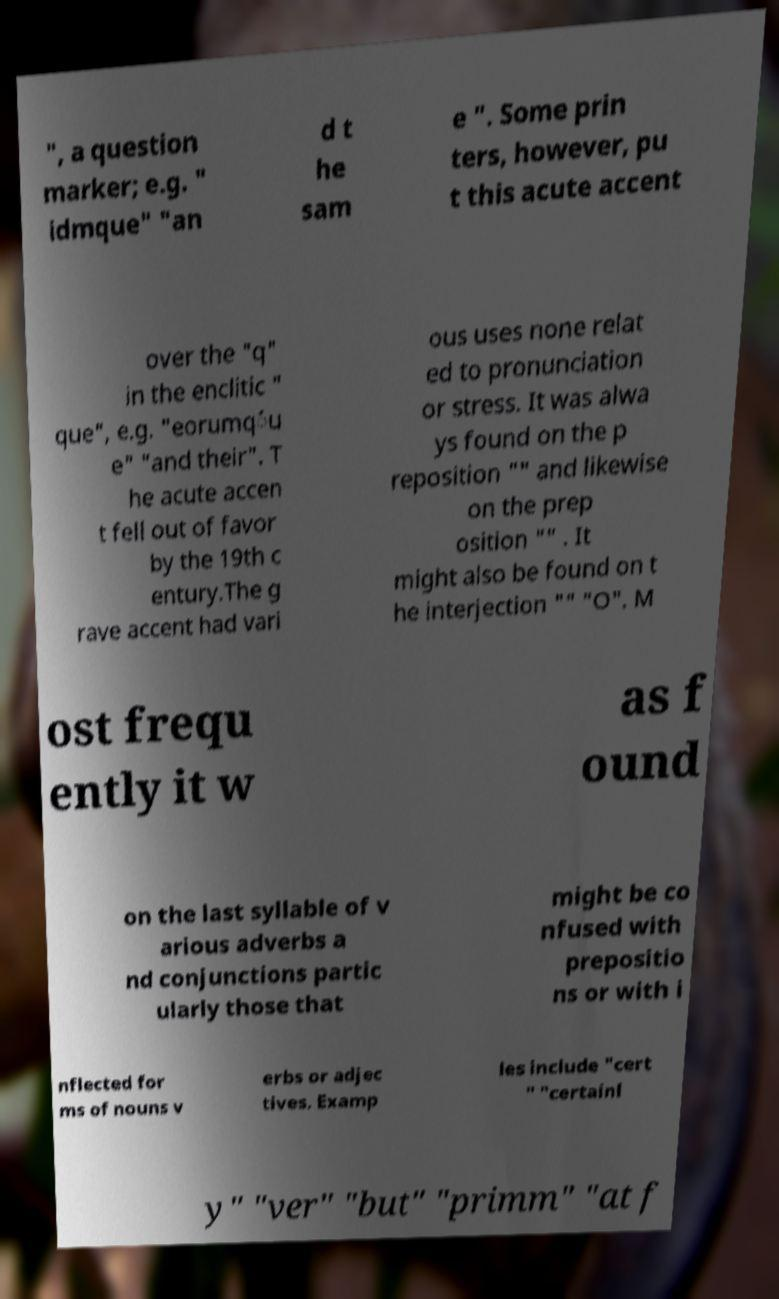Could you extract and type out the text from this image? ", a question marker; e.g. " idmque" "an d t he sam e ". Some prin ters, however, pu t this acute accent over the "q" in the enclitic " que", e.g. "eorumq́u e" "and their". T he acute accen t fell out of favor by the 19th c entury.The g rave accent had vari ous uses none relat ed to pronunciation or stress. It was alwa ys found on the p reposition "" and likewise on the prep osition "" . It might also be found on t he interjection "" "O". M ost frequ ently it w as f ound on the last syllable of v arious adverbs a nd conjunctions partic ularly those that might be co nfused with prepositio ns or with i nflected for ms of nouns v erbs or adjec tives. Examp les include "cert " "certainl y" "ver" "but" "primm" "at f 